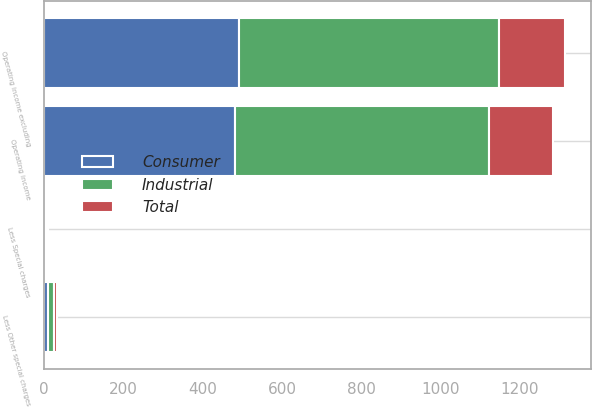<chart> <loc_0><loc_0><loc_500><loc_500><stacked_bar_chart><ecel><fcel>Operating income excluding<fcel>Less Other special charges<fcel>Operating income<fcel>Less Special charges<nl><fcel>Consumer<fcel>490.8<fcel>8.9<fcel>481.6<fcel>3.7<nl><fcel>Total<fcel>166.2<fcel>6.8<fcel>159.4<fcel>1.5<nl><fcel>Industrial<fcel>657<fcel>15.7<fcel>641<fcel>5.2<nl></chart> 